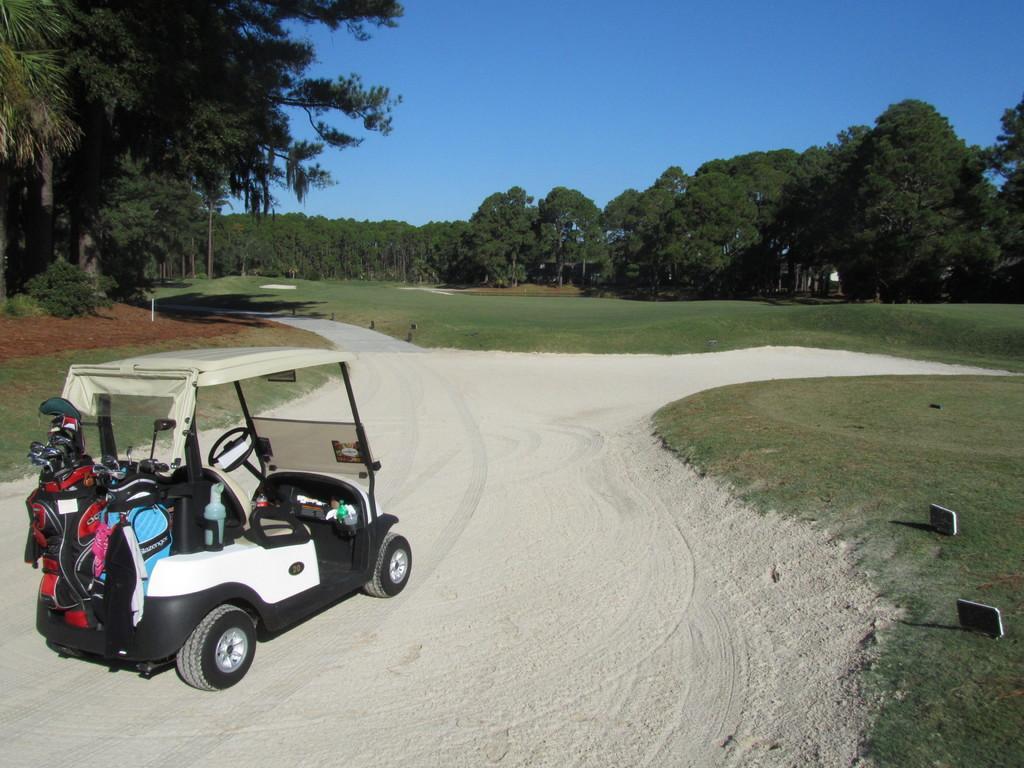How would you summarize this image in a sentence or two? In this image I can see a sand way in a garden. I can see a vehicle on the sand I can see trees in the center of the image At the top of the image I can see the sky. 